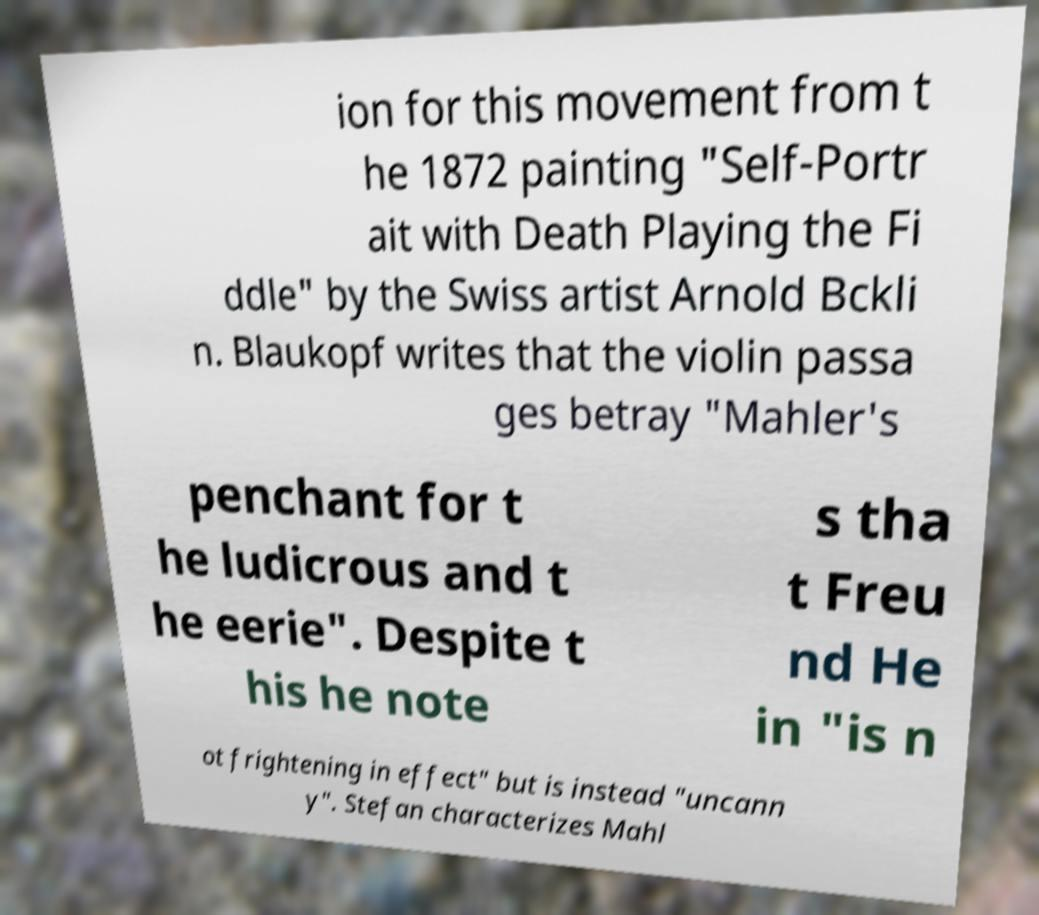Please read and relay the text visible in this image. What does it say? ion for this movement from t he 1872 painting "Self-Portr ait with Death Playing the Fi ddle" by the Swiss artist Arnold Bckli n. Blaukopf writes that the violin passa ges betray "Mahler's penchant for t he ludicrous and t he eerie". Despite t his he note s tha t Freu nd He in "is n ot frightening in effect" but is instead "uncann y". Stefan characterizes Mahl 